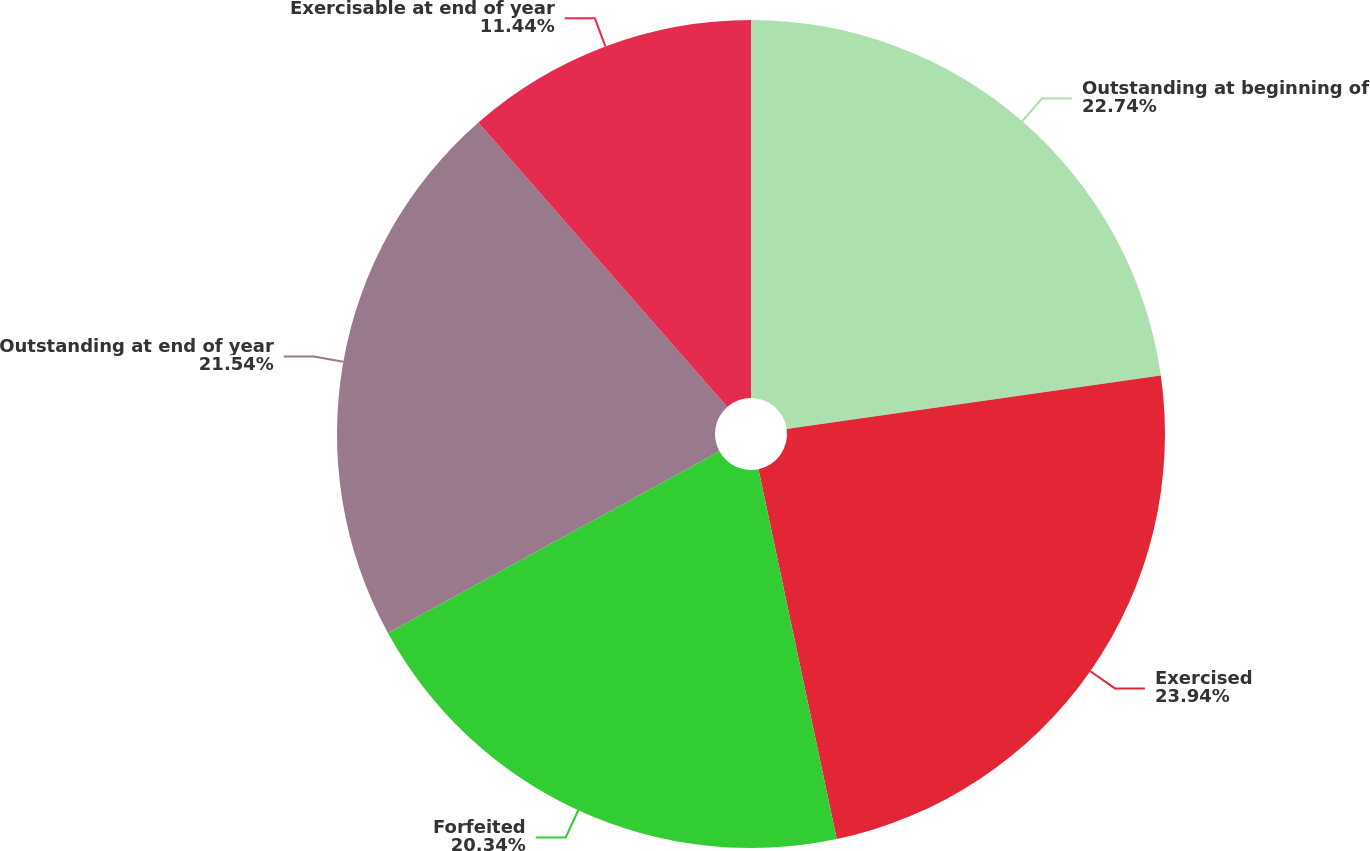<chart> <loc_0><loc_0><loc_500><loc_500><pie_chart><fcel>Outstanding at beginning of<fcel>Exercised<fcel>Forfeited<fcel>Outstanding at end of year<fcel>Exercisable at end of year<nl><fcel>22.74%<fcel>23.94%<fcel>20.34%<fcel>21.54%<fcel>11.44%<nl></chart> 